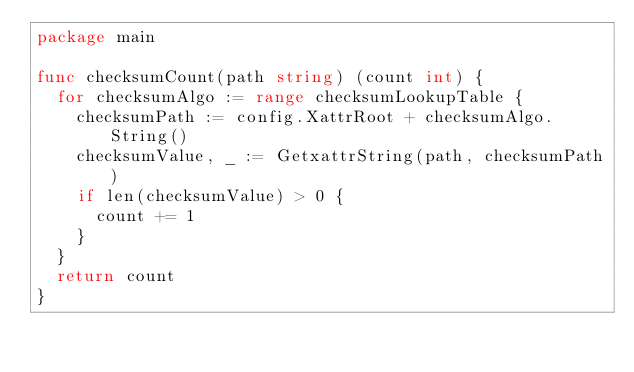Convert code to text. <code><loc_0><loc_0><loc_500><loc_500><_Go_>package main

func checksumCount(path string) (count int) {
	for checksumAlgo := range checksumLookupTable {
		checksumPath := config.XattrRoot + checksumAlgo.String()
		checksumValue, _ := GetxattrString(path, checksumPath)
		if len(checksumValue) > 0 {
			count += 1
		}
	}
	return count
}
</code> 